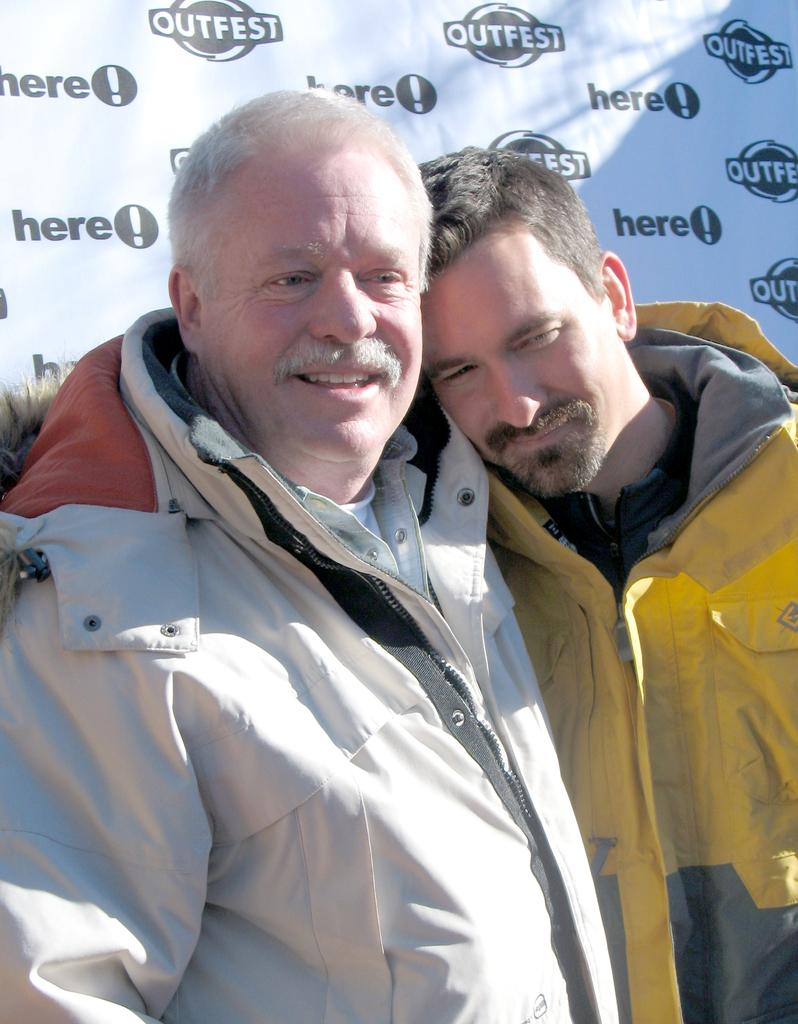How many people are in the image? There are two men in the image. What are the men wearing? The men are wearing jackets. What can be seen behind the men in the image? There appears to be a banner behind the men. What type of office furniture can be seen in the image? There is no office furniture present in the image. Can you describe the conversation the men are having in the image? There is no conversation depicted in the image, as it only shows the two men and a banner. 